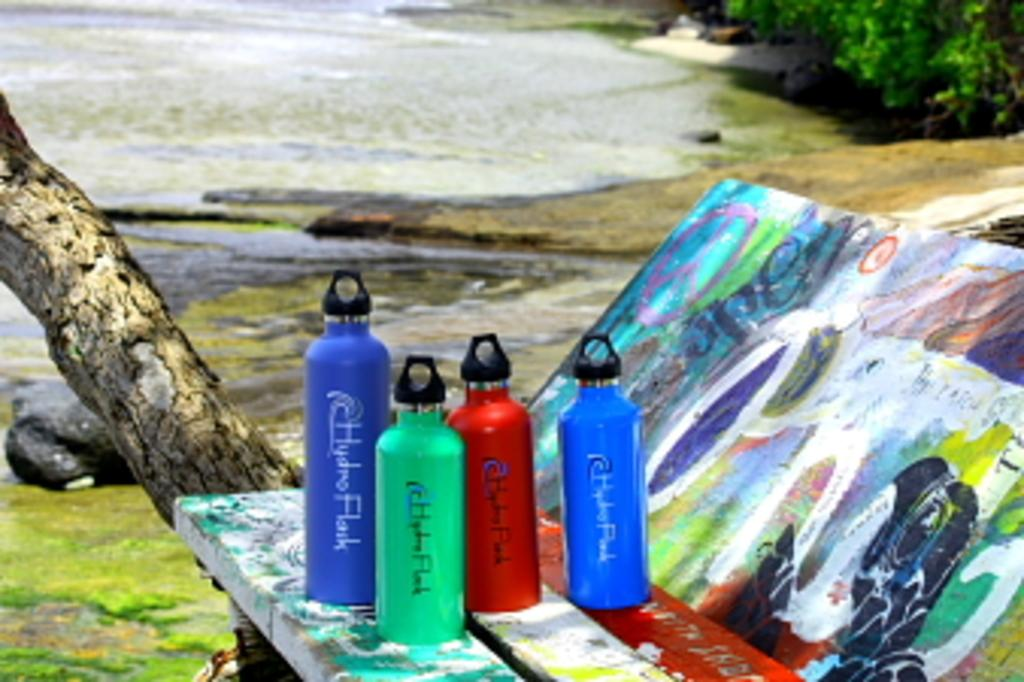<image>
Create a compact narrative representing the image presented. The HydroFlak bottles are available in four different colors and two different sizes. 